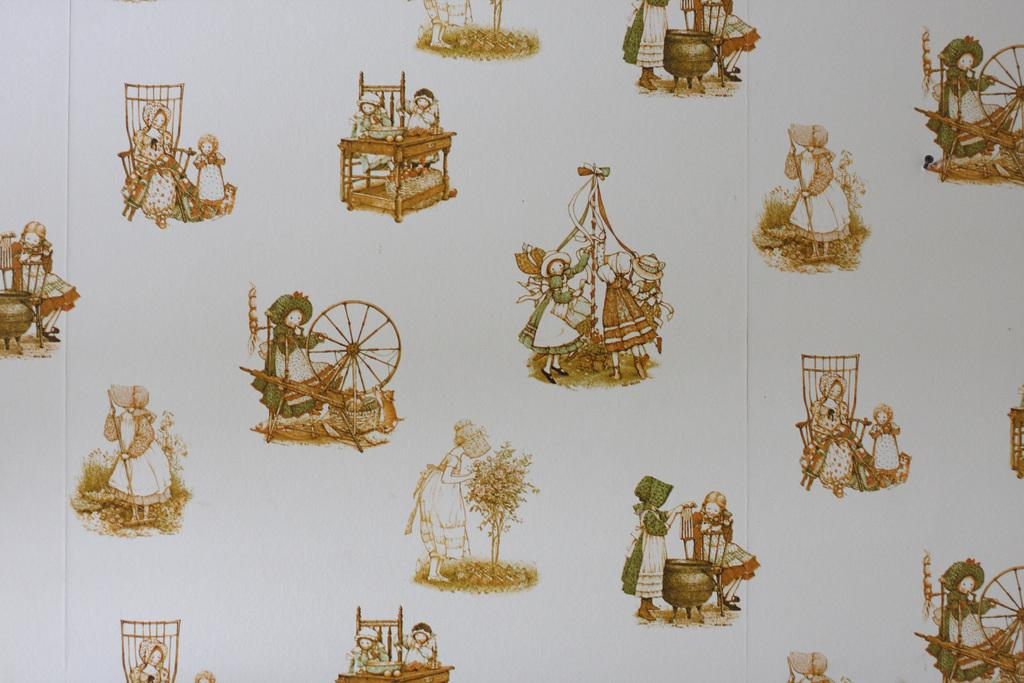What type of decorative element is present in the image? There are wallpapers with designs in the image. What is the wallpapers applied to in the image? The wallpapers are on an object. What fictional character can be observed in the image? There is no fictional character present in the image; it only features wallpapers with designs on an object. 